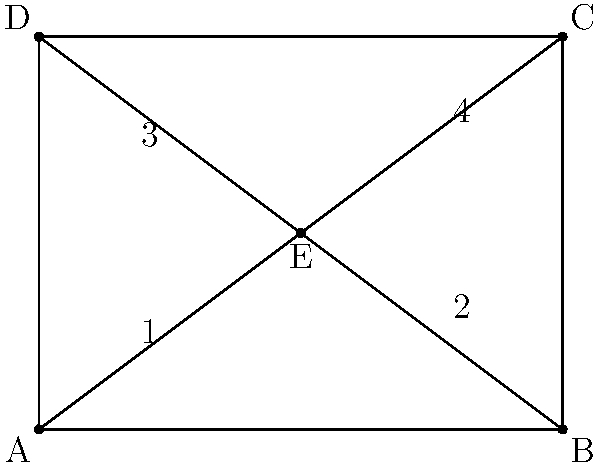As you design trail markers for a new nature trail, you notice that the markers form a rectangle ABCD with diagonals intersecting at point E. Which pairs of angles are congruent in this configuration? Let's analyze this step-by-step:

1. In a rectangle, opposite angles are congruent. Therefore:
   ∠DAB ≅ ∠BCD and ∠ABC ≅ ∠CDA

2. The diagonals of a rectangle bisect each other. This means:
   AE ≅ EC and BE ≅ ED

3. When two lines intersect, vertical angles are congruent. Therefore:
   ∠1 ≅ ∠3 and ∠2 ≅ ∠4

4. In a rectangle, diagonals are congruent. So:
   AC ≅ BD

5. Given that the diagonals are congruent and bisect each other, we can conclude that triangles AEB, BEC, CED, and DEA are all congruent.

6. This means that all angles formed by a diagonal and a side of the rectangle are congruent:
   ∠1 ≅ ∠2 ≅ ∠3 ≅ ∠4

Therefore, angles 1, 2, 3, and 4 are all congruent to each other.
Answer: ∠1 ≅ ∠2 ≅ ∠3 ≅ ∠4 